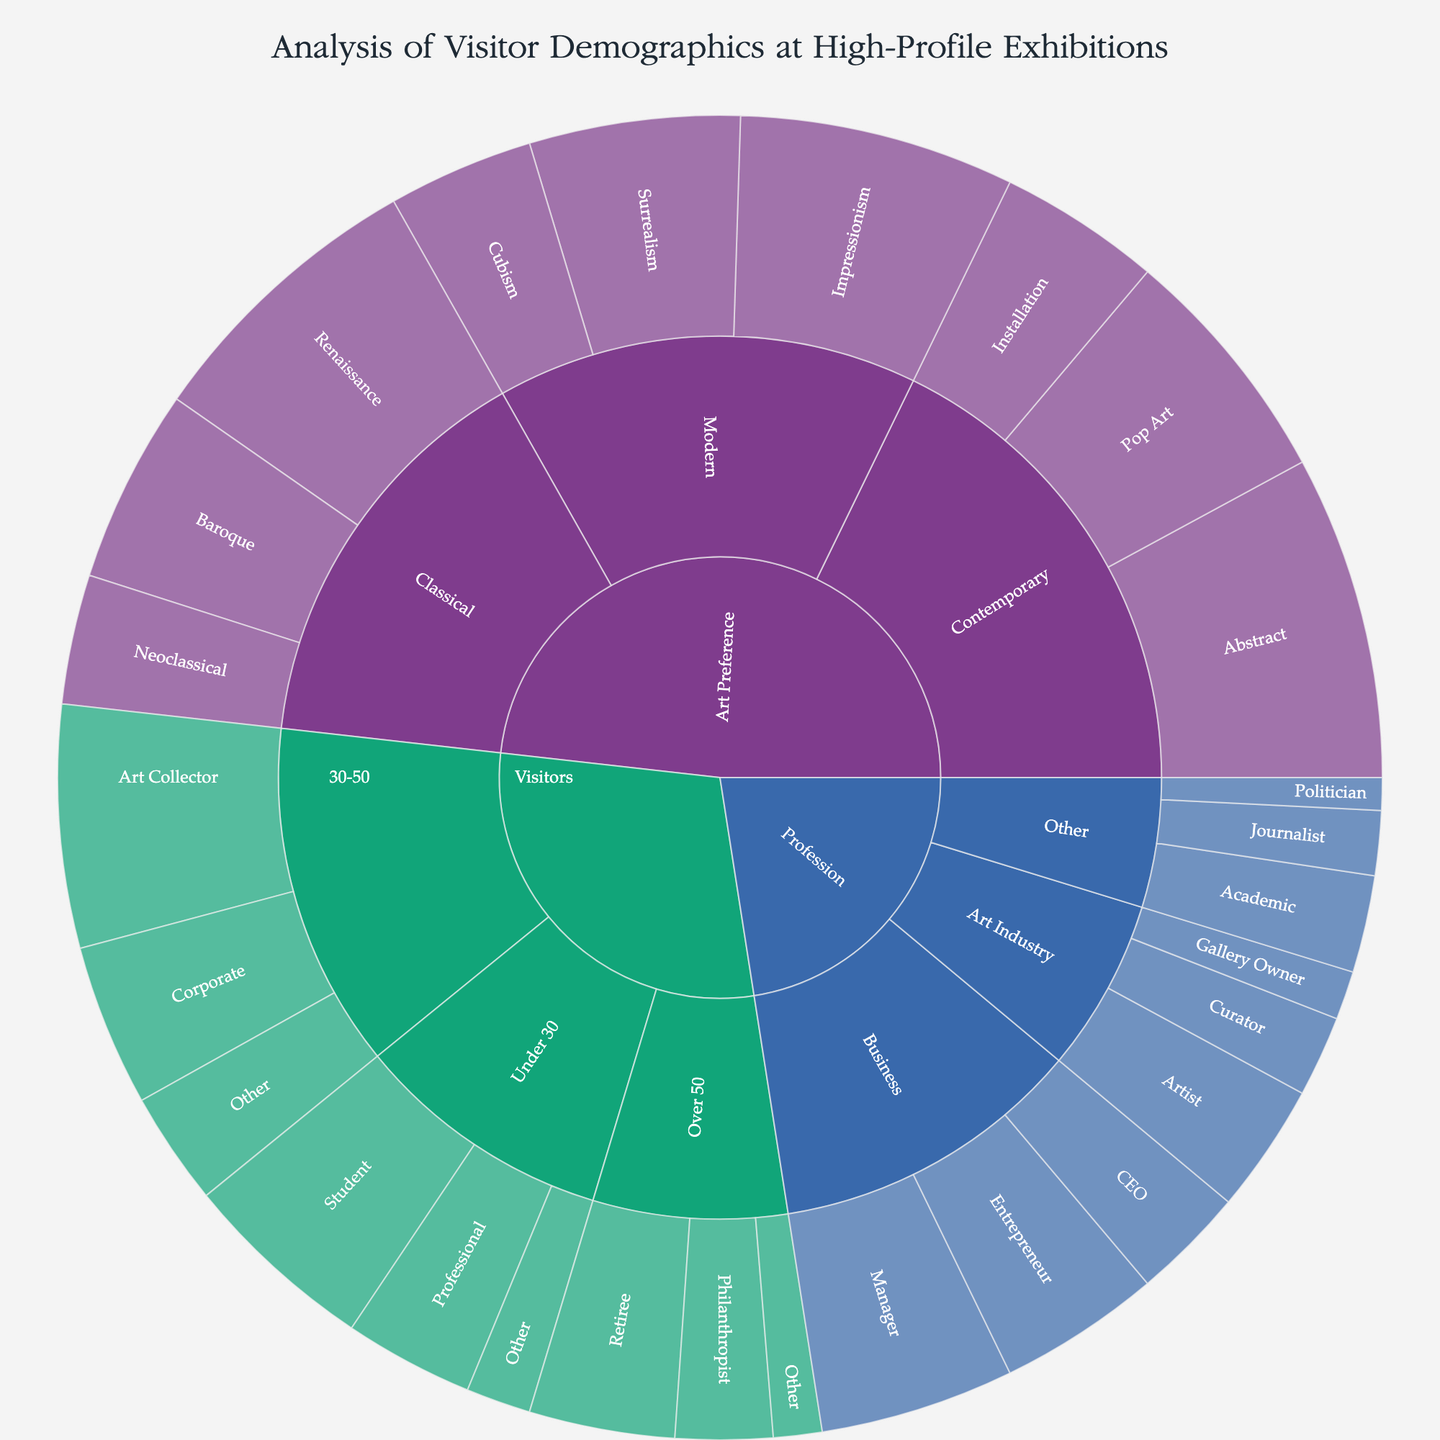What is the title of the figure? Look at the top section of the figure where the title is typically displayed. The title is clearly indicated.
Answer: Analysis of Visitor Demographics at High-Profile Exhibitions Among visitors under 30, which subcategory has the highest number of visitors? Identify the segments within the "Under 30" category and compare their values. The segment with the largest value is the answer.
Answer: Student What is the total number of visitors aged 30-50? Sum the values of all subcategories under the "30-50" category: (150 + 100 + 70)
Answer: 320 How does the number of Retirees over 50 compare to the number of Visitors under 30 who are Students? Compare the provided values for Retirees (90) and Students (120).
Answer: Students under 30 are more than Retirees over 50 Which art preference subcategory has the highest value within Classical art? Look at the subcategories under "Classical" and compare their values. The highest value subcategory is the answer.
Answer: Renaissance What is the combined value of Art Collectors and Corporate professionals in the 30-50 age group? Add the values for Art Collectors (150) and Corporate (100): (150 + 100)
Answer: 250 Which profession within the Art Industry category has the lowest number of visitors? Compare the values of subcategories under "Art Industry." Identify the subcategory with the lowest value.
Answer: Gallery Owner What’s the difference in population between Contemporary Abstract art lovers and Classical Renaissance art lovers? Subtract the value of Classical Renaissance (180) from Contemporary Abstract (200): (200 - 180)
Answer: 20 Among the subcategories of Contemporary art preferences, which has the least value? Compare the values within the "Contemporary" subcategories and determine the lowest value.
Answer: Installation How many more Modern Impressionism lovers are there compared to Modern Cubism lovers? Subtract the value of Modern Cubism (90) from Modern Impressionism (170): (170 - 90)
Answer: 80 